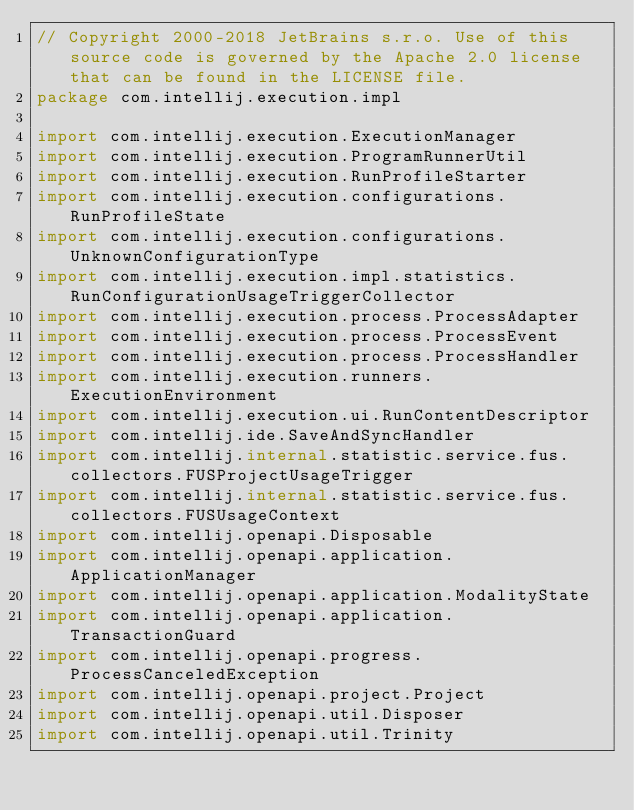Convert code to text. <code><loc_0><loc_0><loc_500><loc_500><_Kotlin_>// Copyright 2000-2018 JetBrains s.r.o. Use of this source code is governed by the Apache 2.0 license that can be found in the LICENSE file.
package com.intellij.execution.impl

import com.intellij.execution.ExecutionManager
import com.intellij.execution.ProgramRunnerUtil
import com.intellij.execution.RunProfileStarter
import com.intellij.execution.configurations.RunProfileState
import com.intellij.execution.configurations.UnknownConfigurationType
import com.intellij.execution.impl.statistics.RunConfigurationUsageTriggerCollector
import com.intellij.execution.process.ProcessAdapter
import com.intellij.execution.process.ProcessEvent
import com.intellij.execution.process.ProcessHandler
import com.intellij.execution.runners.ExecutionEnvironment
import com.intellij.execution.ui.RunContentDescriptor
import com.intellij.ide.SaveAndSyncHandler
import com.intellij.internal.statistic.service.fus.collectors.FUSProjectUsageTrigger
import com.intellij.internal.statistic.service.fus.collectors.FUSUsageContext
import com.intellij.openapi.Disposable
import com.intellij.openapi.application.ApplicationManager
import com.intellij.openapi.application.ModalityState
import com.intellij.openapi.application.TransactionGuard
import com.intellij.openapi.progress.ProcessCanceledException
import com.intellij.openapi.project.Project
import com.intellij.openapi.util.Disposer
import com.intellij.openapi.util.Trinity</code> 